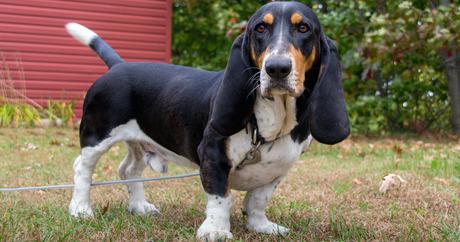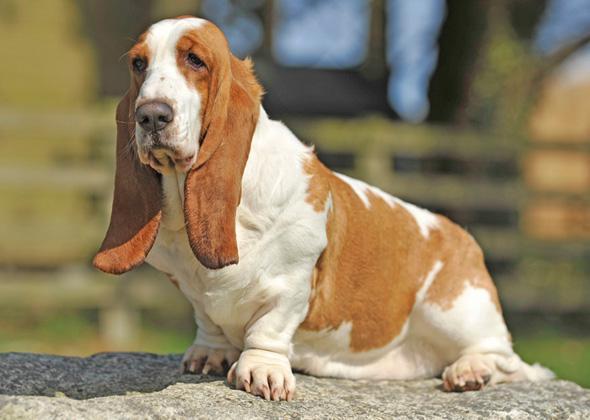The first image is the image on the left, the second image is the image on the right. Analyze the images presented: Is the assertion "There are at least two dogs sitting in the image on the left." valid? Answer yes or no. No. The first image is the image on the left, the second image is the image on the right. For the images shown, is this caption "An image contains exactly one basset hound, which has tan and white coloring." true? Answer yes or no. Yes. 